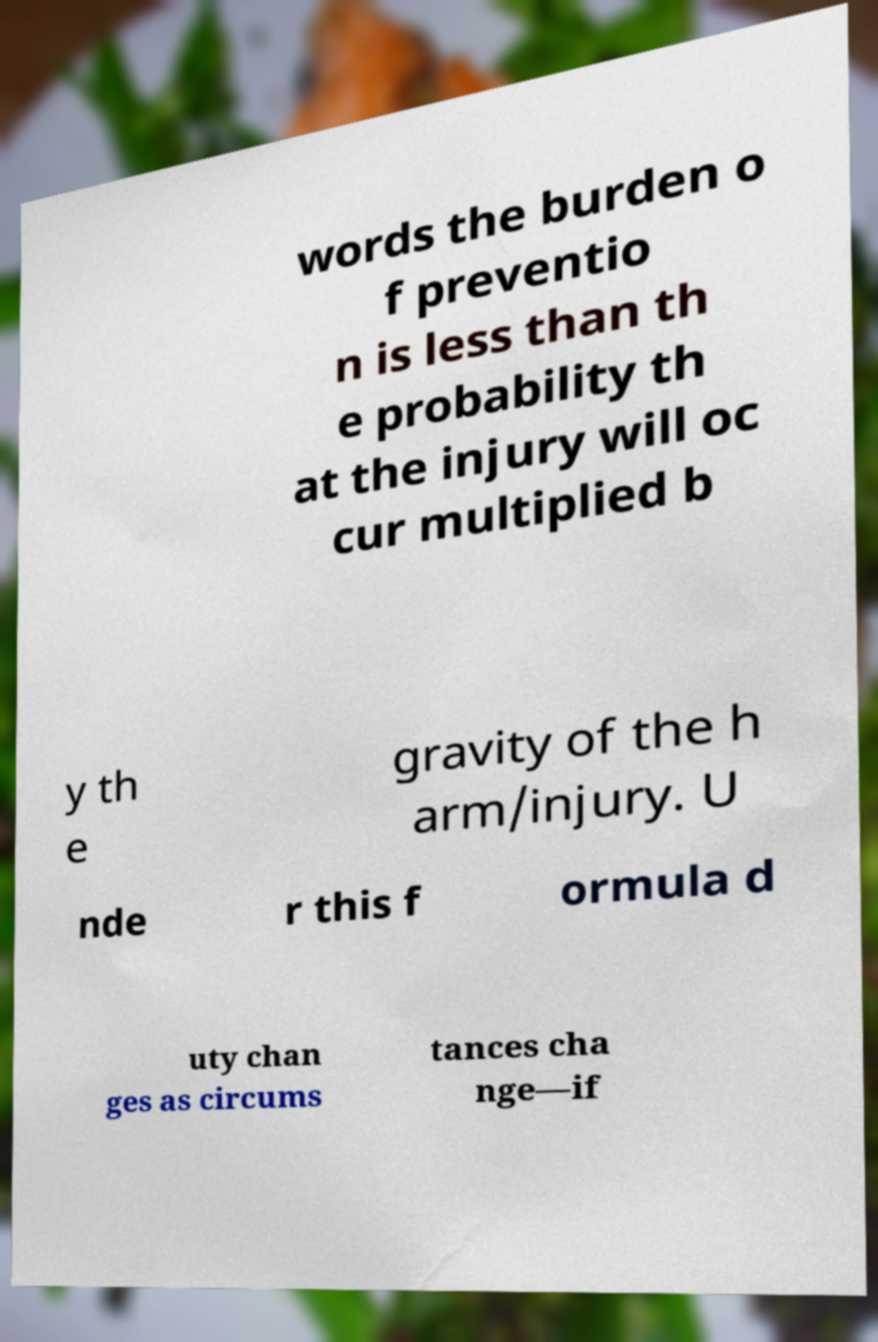Could you extract and type out the text from this image? words the burden o f preventio n is less than th e probability th at the injury will oc cur multiplied b y th e gravity of the h arm/injury. U nde r this f ormula d uty chan ges as circums tances cha nge—if 